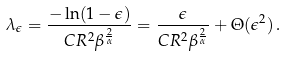Convert formula to latex. <formula><loc_0><loc_0><loc_500><loc_500>\lambda _ { \epsilon } = \frac { - \ln ( 1 - \epsilon ) } { C R ^ { 2 } \beta ^ { \frac { 2 } { \alpha } } } = \frac { \epsilon } { C R ^ { 2 } \beta ^ { \frac { 2 } { \alpha } } } + \Theta ( \epsilon ^ { 2 } ) \, .</formula> 